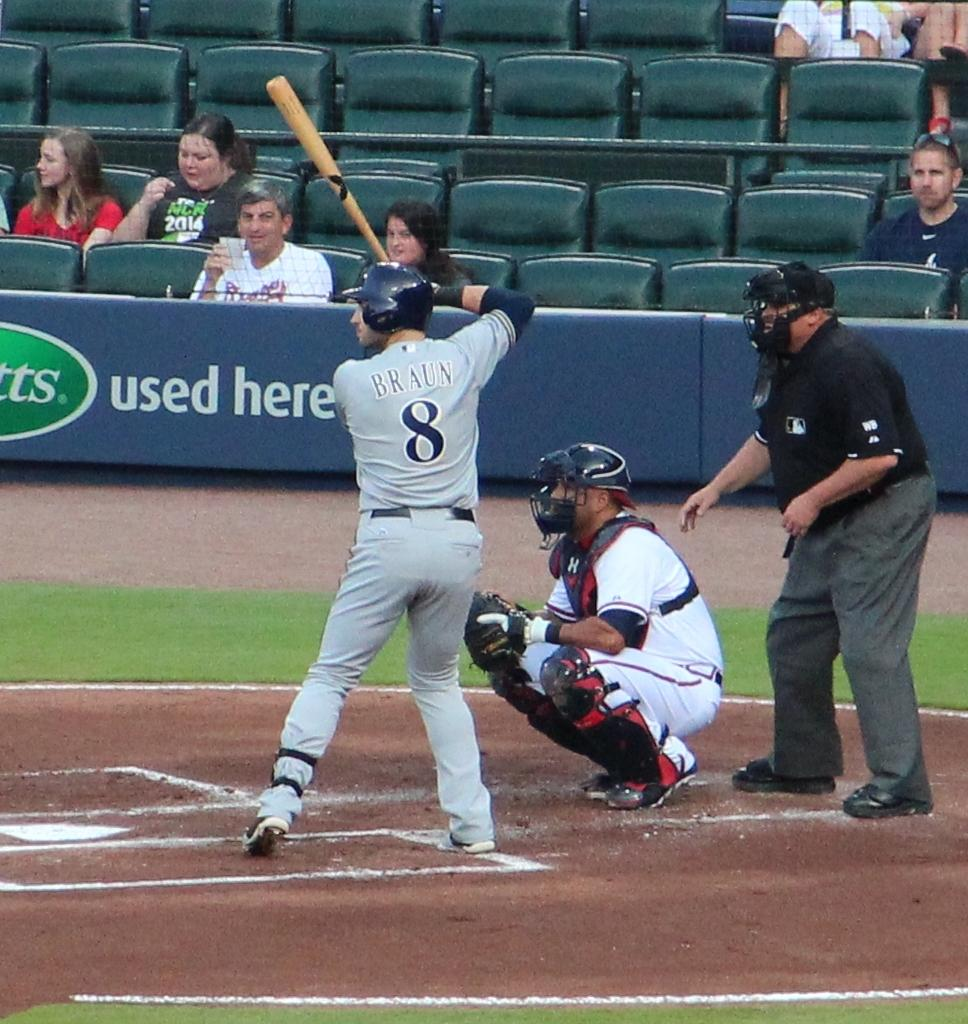<image>
Relay a brief, clear account of the picture shown. The baseball player with the last name "Braun" is preparing to swing his bat 